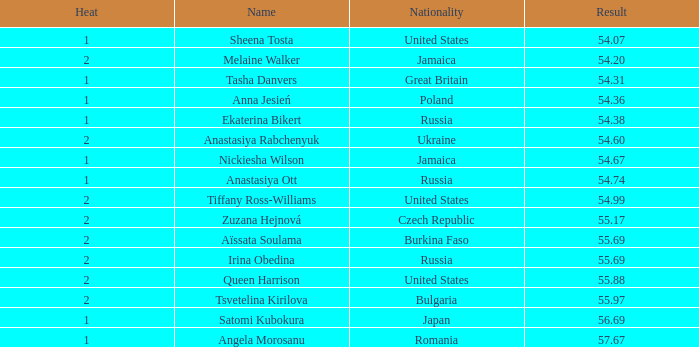Which Nationality has a Heat smaller than 2, and a Rank of 15? Japan. Could you parse the entire table? {'header': ['Heat', 'Name', 'Nationality', 'Result'], 'rows': [['1', 'Sheena Tosta', 'United States', '54.07'], ['2', 'Melaine Walker', 'Jamaica', '54.20'], ['1', 'Tasha Danvers', 'Great Britain', '54.31'], ['1', 'Anna Jesień', 'Poland', '54.36'], ['1', 'Ekaterina Bikert', 'Russia', '54.38'], ['2', 'Anastasiya Rabchenyuk', 'Ukraine', '54.60'], ['1', 'Nickiesha Wilson', 'Jamaica', '54.67'], ['1', 'Anastasiya Ott', 'Russia', '54.74'], ['2', 'Tiffany Ross-Williams', 'United States', '54.99'], ['2', 'Zuzana Hejnová', 'Czech Republic', '55.17'], ['2', 'Aïssata Soulama', 'Burkina Faso', '55.69'], ['2', 'Irina Obedina', 'Russia', '55.69'], ['2', 'Queen Harrison', 'United States', '55.88'], ['2', 'Tsvetelina Kirilova', 'Bulgaria', '55.97'], ['1', 'Satomi Kubokura', 'Japan', '56.69'], ['1', 'Angela Morosanu', 'Romania', '57.67']]} 